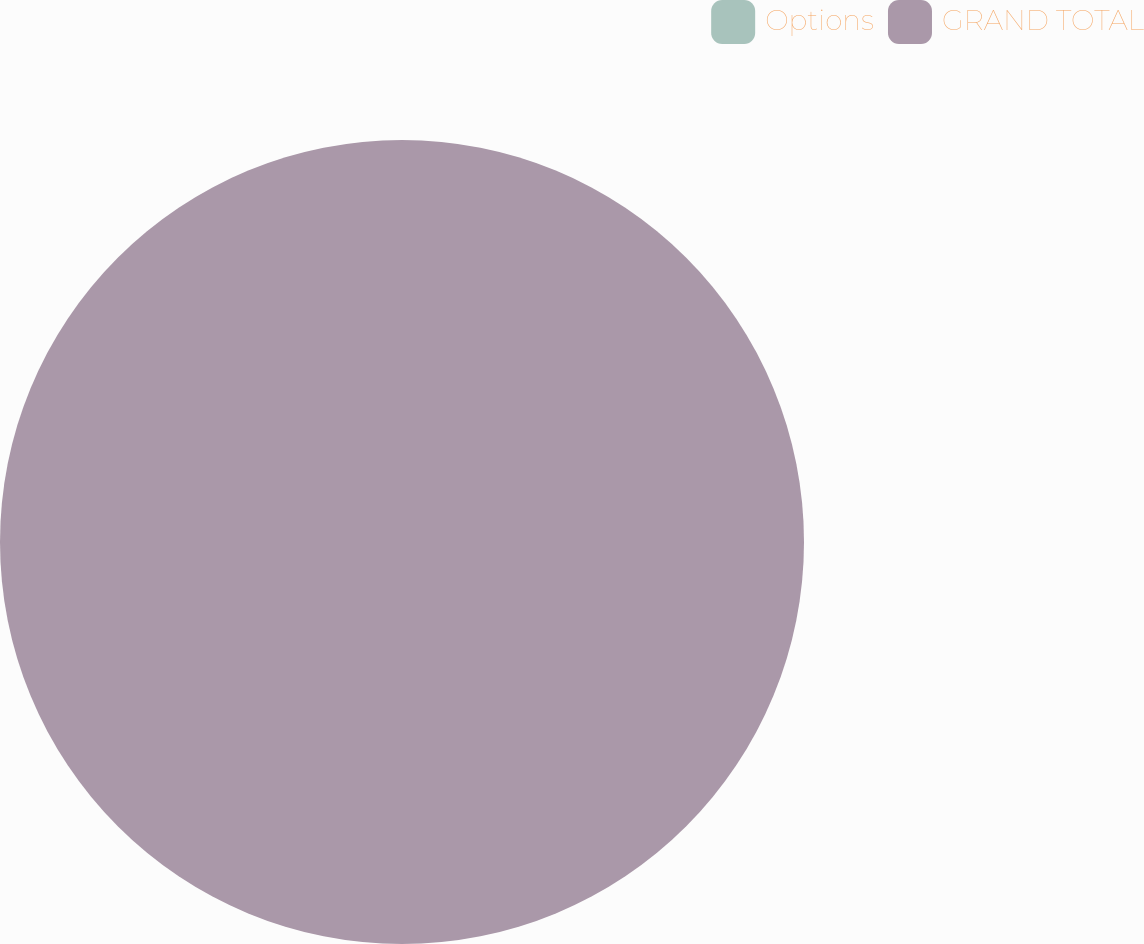<chart> <loc_0><loc_0><loc_500><loc_500><pie_chart><fcel>Options<fcel>GRAND TOTAL<nl><fcel>0.0%<fcel>100.0%<nl></chart> 